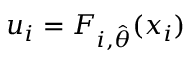Convert formula to latex. <formula><loc_0><loc_0><loc_500><loc_500>u _ { i } = F _ { i , \hat { \theta } } ( x _ { i } )</formula> 